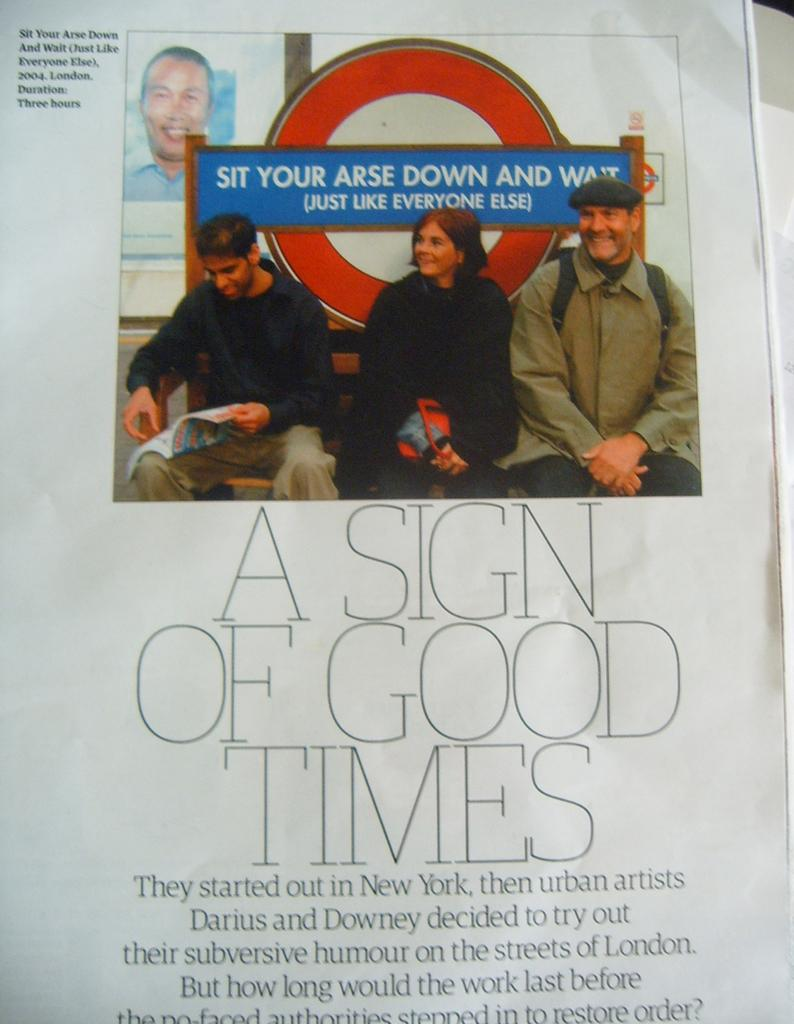What is present on the poster in the image? There is a poster in the image. What type of images are on the poster? The poster contains images of two men and a woman. Is there any text on the poster? Yes, there is text on the poster. What type of trade is being conducted in the image? There is no indication of any trade being conducted in the image; it features a poster with images of two men and a woman. What type of apple can be seen growing on the poster? There is no apple present on the poster; it contains images of two men and a woman, along with text. 